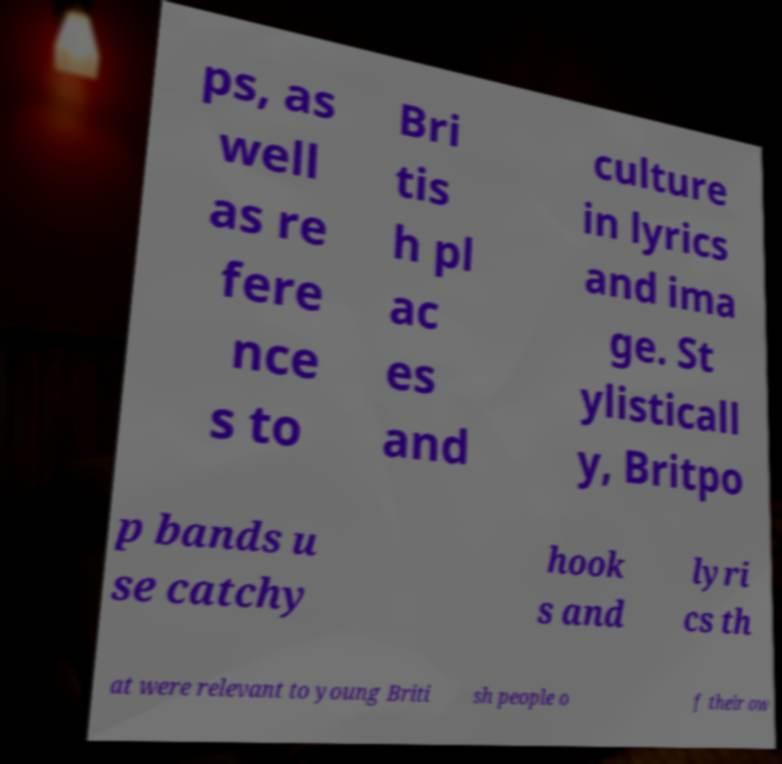For documentation purposes, I need the text within this image transcribed. Could you provide that? ps, as well as re fere nce s to Bri tis h pl ac es and culture in lyrics and ima ge. St ylisticall y, Britpo p bands u se catchy hook s and lyri cs th at were relevant to young Briti sh people o f their ow 